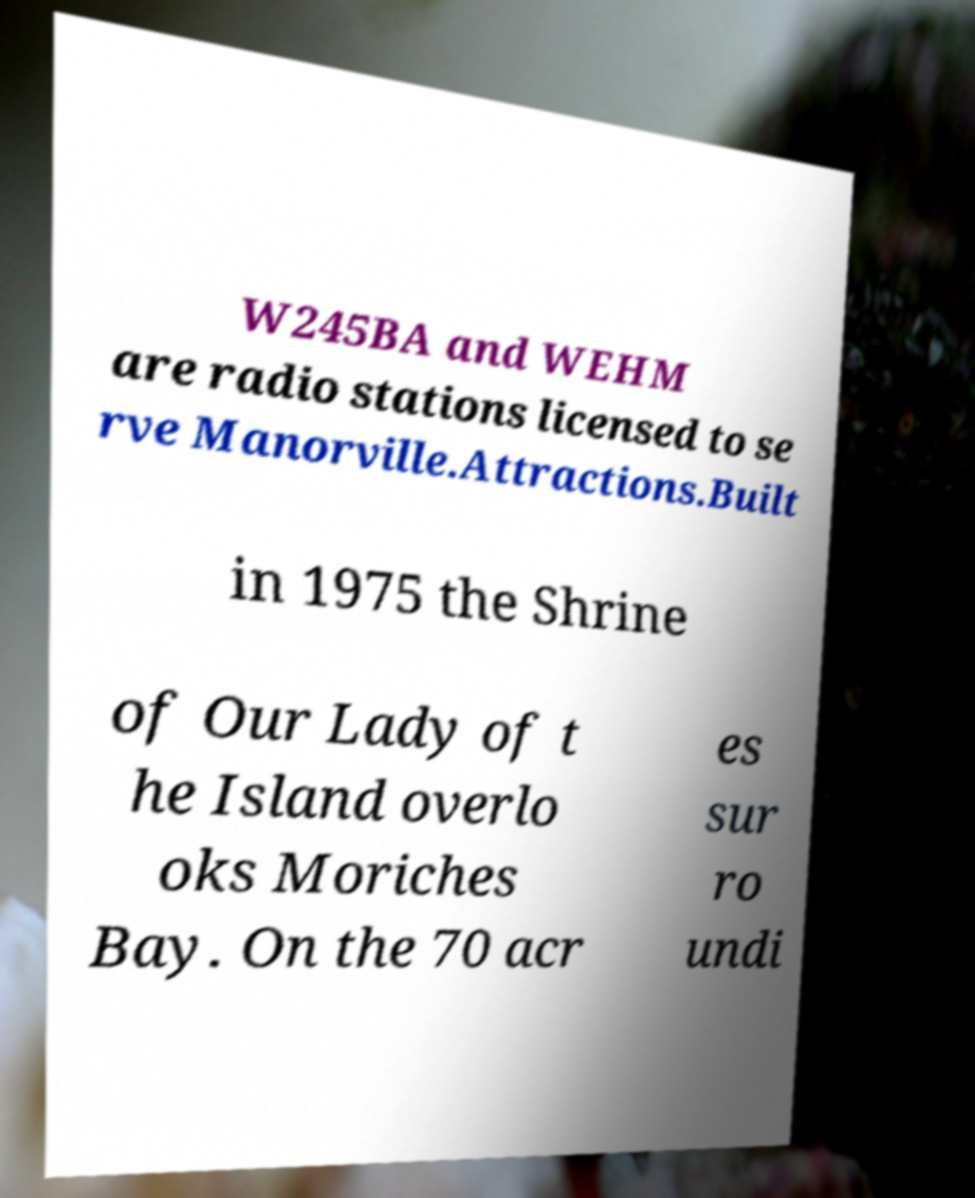Please read and relay the text visible in this image. What does it say? W245BA and WEHM are radio stations licensed to se rve Manorville.Attractions.Built in 1975 the Shrine of Our Lady of t he Island overlo oks Moriches Bay. On the 70 acr es sur ro undi 